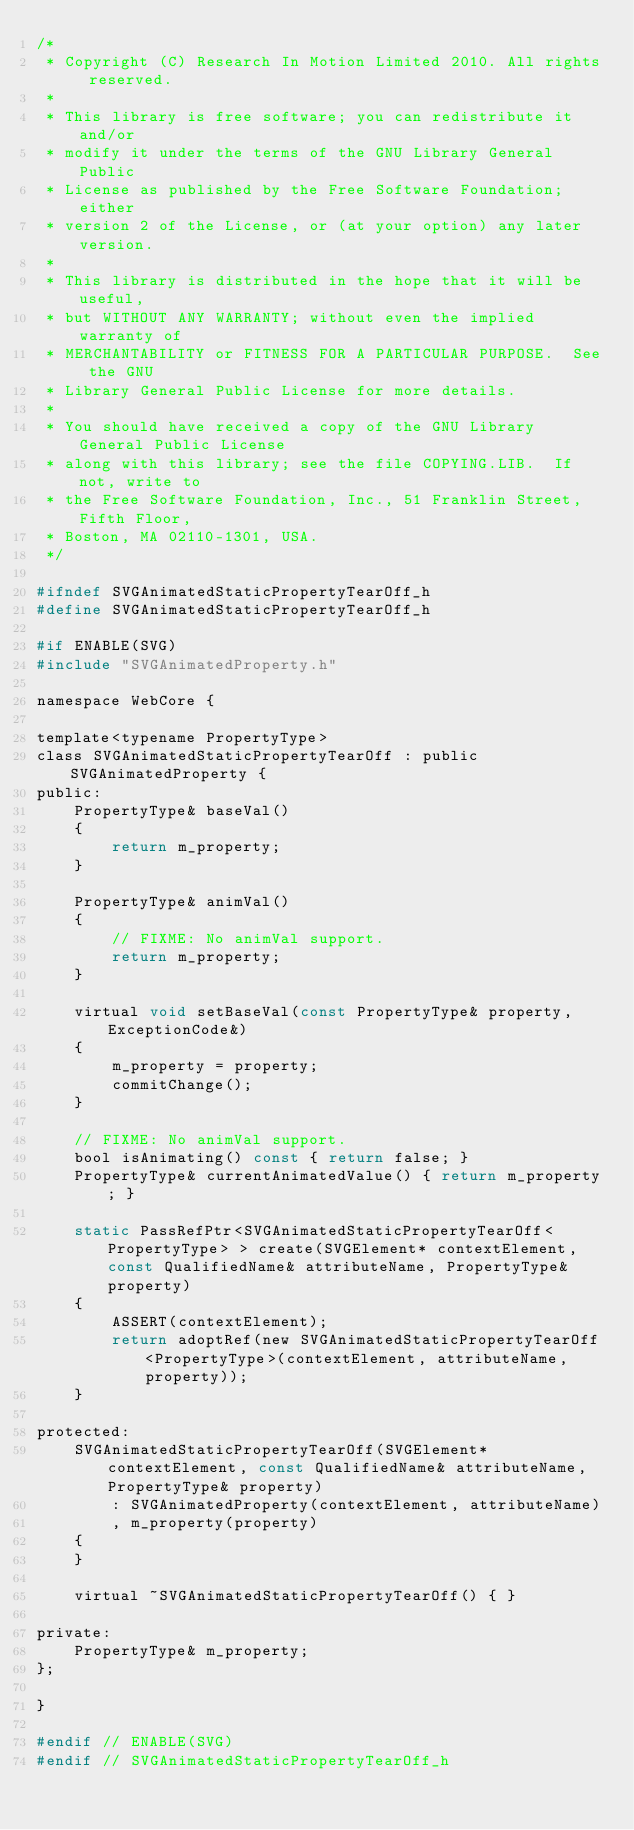<code> <loc_0><loc_0><loc_500><loc_500><_C_>/*
 * Copyright (C) Research In Motion Limited 2010. All rights reserved.
 *
 * This library is free software; you can redistribute it and/or
 * modify it under the terms of the GNU Library General Public
 * License as published by the Free Software Foundation; either
 * version 2 of the License, or (at your option) any later version.
 *
 * This library is distributed in the hope that it will be useful,
 * but WITHOUT ANY WARRANTY; without even the implied warranty of
 * MERCHANTABILITY or FITNESS FOR A PARTICULAR PURPOSE.  See the GNU
 * Library General Public License for more details.
 *
 * You should have received a copy of the GNU Library General Public License
 * along with this library; see the file COPYING.LIB.  If not, write to
 * the Free Software Foundation, Inc., 51 Franklin Street, Fifth Floor,
 * Boston, MA 02110-1301, USA.
 */

#ifndef SVGAnimatedStaticPropertyTearOff_h
#define SVGAnimatedStaticPropertyTearOff_h

#if ENABLE(SVG)
#include "SVGAnimatedProperty.h"

namespace WebCore {

template<typename PropertyType>
class SVGAnimatedStaticPropertyTearOff : public SVGAnimatedProperty {
public:
    PropertyType& baseVal()
    {
        return m_property;
    }

    PropertyType& animVal()
    {
        // FIXME: No animVal support.
        return m_property;
    }

    virtual void setBaseVal(const PropertyType& property, ExceptionCode&)
    {
        m_property = property;
        commitChange();
    }

    // FIXME: No animVal support.
    bool isAnimating() const { return false; }
    PropertyType& currentAnimatedValue() { return m_property; }

    static PassRefPtr<SVGAnimatedStaticPropertyTearOff<PropertyType> > create(SVGElement* contextElement, const QualifiedName& attributeName, PropertyType& property)
    {
        ASSERT(contextElement);
        return adoptRef(new SVGAnimatedStaticPropertyTearOff<PropertyType>(contextElement, attributeName, property));
    }

protected:
    SVGAnimatedStaticPropertyTearOff(SVGElement* contextElement, const QualifiedName& attributeName, PropertyType& property)
        : SVGAnimatedProperty(contextElement, attributeName)
        , m_property(property)
    {
    }

    virtual ~SVGAnimatedStaticPropertyTearOff() { }

private:
    PropertyType& m_property;
};

}

#endif // ENABLE(SVG)
#endif // SVGAnimatedStaticPropertyTearOff_h
</code> 